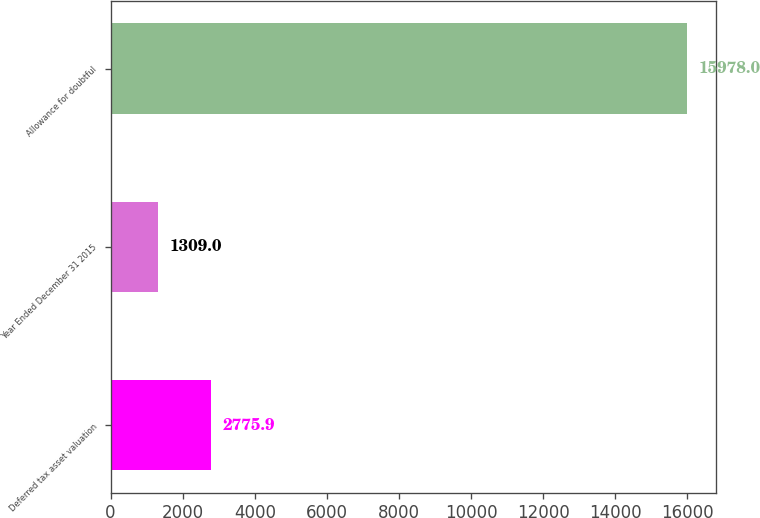Convert chart to OTSL. <chart><loc_0><loc_0><loc_500><loc_500><bar_chart><fcel>Deferred tax asset valuation<fcel>Year Ended December 31 2015<fcel>Allowance for doubtful<nl><fcel>2775.9<fcel>1309<fcel>15978<nl></chart> 